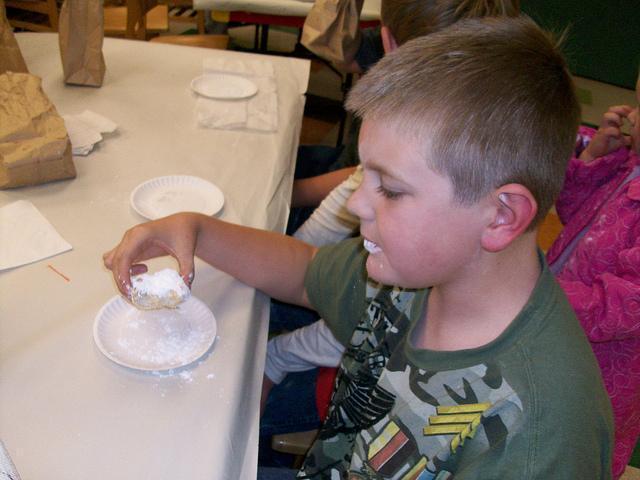How many plates are on the table?
Give a very brief answer. 3. How many people are there?
Give a very brief answer. 3. 